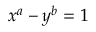Convert formula to latex. <formula><loc_0><loc_0><loc_500><loc_500>x ^ { a } - y ^ { b } = 1</formula> 